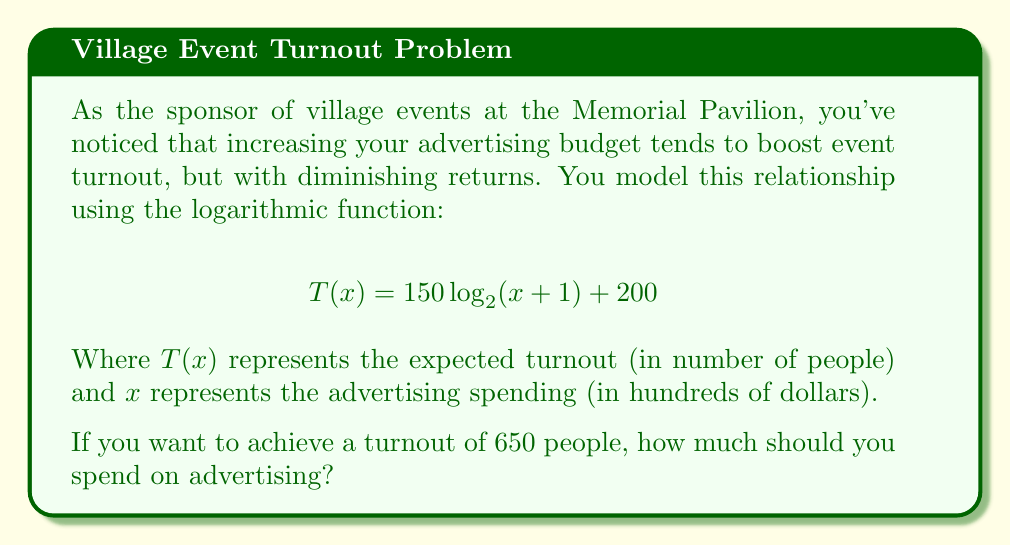Solve this math problem. Let's approach this step-by-step:

1) We're given the function $T(x) = 150 \log_2(x + 1) + 200$, where we want $T(x) = 650$.

2) Let's substitute this into our equation:

   $650 = 150 \log_2(x + 1) + 200$

3) First, let's subtract 200 from both sides:

   $450 = 150 \log_2(x + 1)$

4) Now, divide both sides by 150:

   $3 = \log_2(x + 1)$

5) To solve for $x$, we need to apply the inverse function of $\log_2$, which is $2^x$:

   $2^3 = x + 1$

6) Simplify the left side:

   $8 = x + 1$

7) Subtract 1 from both sides:

   $7 = x$

8) Remember that $x$ represents hundreds of dollars. So the actual amount is $700.

Therefore, you should spend $700 on advertising to achieve a turnout of 650 people.
Answer: $700 